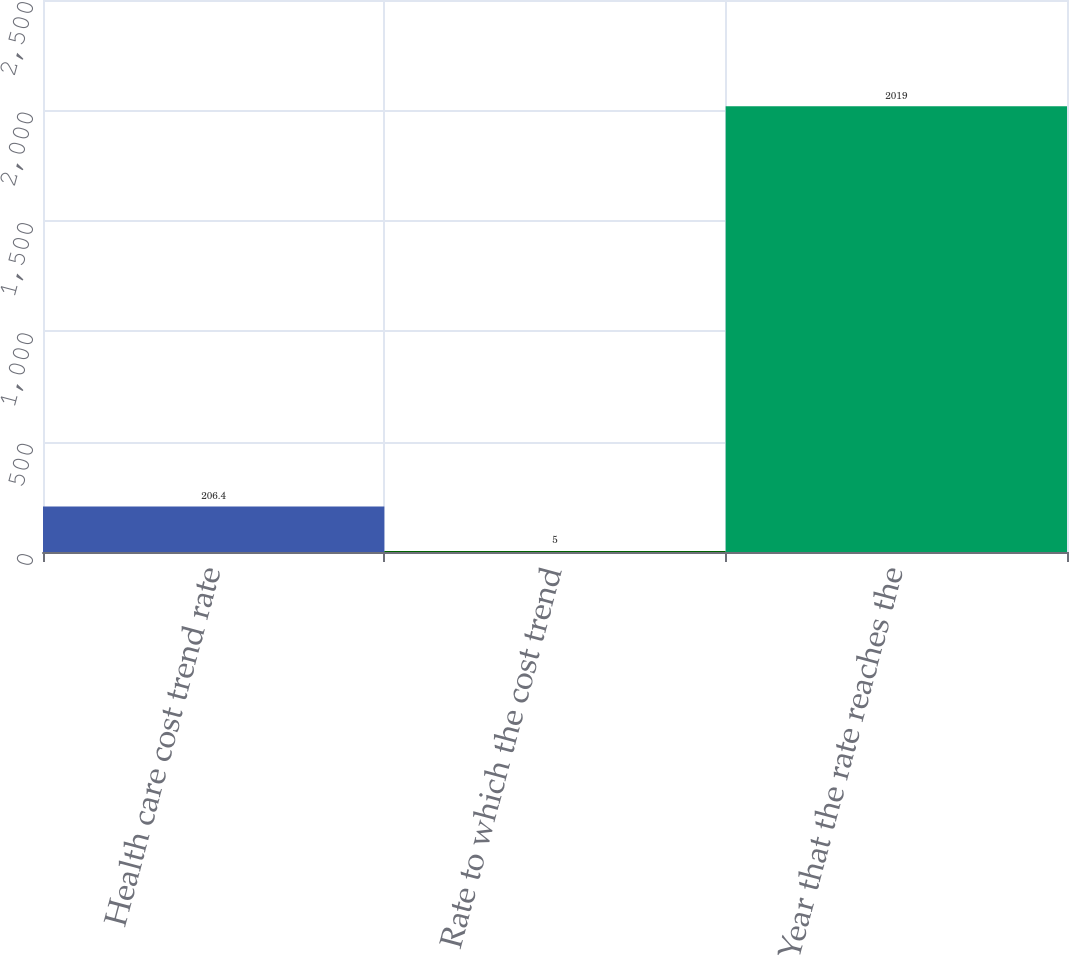<chart> <loc_0><loc_0><loc_500><loc_500><bar_chart><fcel>Health care cost trend rate<fcel>Rate to which the cost trend<fcel>Year that the rate reaches the<nl><fcel>206.4<fcel>5<fcel>2019<nl></chart> 